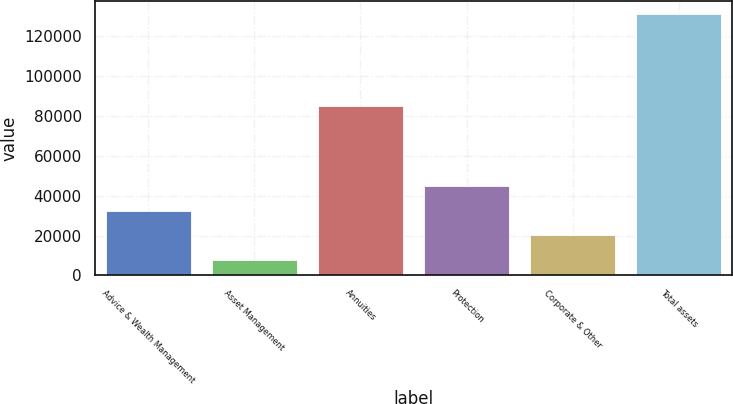<chart> <loc_0><loc_0><loc_500><loc_500><bar_chart><fcel>Advice & Wealth Management<fcel>Asset Management<fcel>Annuities<fcel>Protection<fcel>Corporate & Other<fcel>Total assets<nl><fcel>32526<fcel>7854<fcel>84836<fcel>44862<fcel>20190<fcel>131214<nl></chart> 